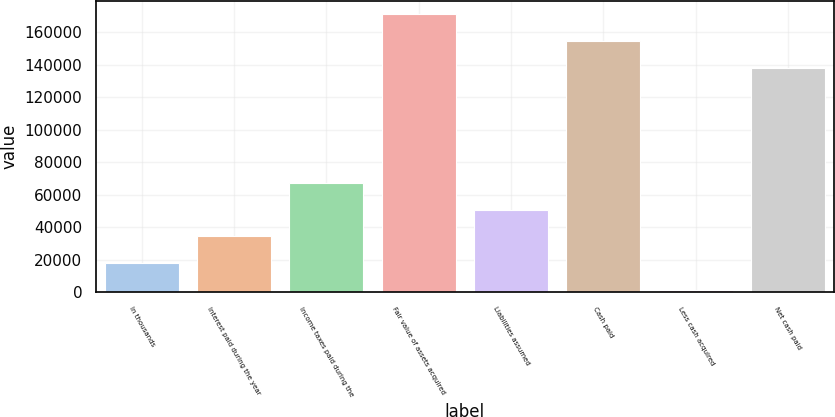Convert chart. <chart><loc_0><loc_0><loc_500><loc_500><bar_chart><fcel>In thousands<fcel>Interest paid during the year<fcel>Income taxes paid during the<fcel>Fair value of assets acquired<fcel>Liabilities assumed<fcel>Cash paid<fcel>Less cash acquired<fcel>Net cash paid<nl><fcel>18017.8<fcel>34465.6<fcel>67361.2<fcel>171094<fcel>50913.4<fcel>154646<fcel>1570<fcel>138198<nl></chart> 